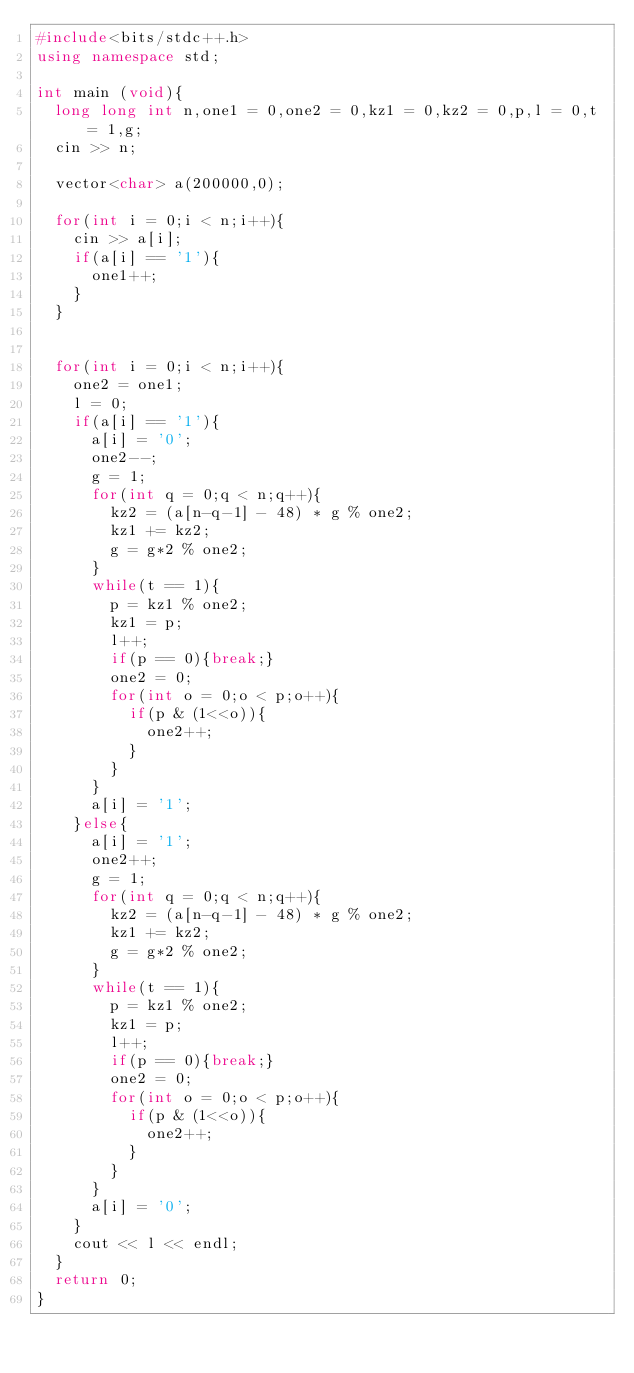<code> <loc_0><loc_0><loc_500><loc_500><_C++_>#include<bits/stdc++.h>
using namespace std;

int main (void){
  long long int n,one1 = 0,one2 = 0,kz1 = 0,kz2 = 0,p,l = 0,t = 1,g;
  cin >> n;

  vector<char> a(200000,0);

  for(int i = 0;i < n;i++){
    cin >> a[i];
    if(a[i] == '1'){
      one1++;
    }
  }


  for(int i = 0;i < n;i++){
    one2 = one1;
    l = 0;
    if(a[i] == '1'){
      a[i] = '0';
      one2--;
      g = 1;
      for(int q = 0;q < n;q++){
        kz2 = (a[n-q-1] - 48) * g % one2;
        kz1 += kz2;
        g = g*2 % one2;
      }
      while(t == 1){
        p = kz1 % one2;
        kz1 = p;
        l++;
        if(p == 0){break;}
        one2 = 0;
        for(int o = 0;o < p;o++){
          if(p & (1<<o)){
            one2++;
          }
        }
      }
      a[i] = '1';
    }else{
      a[i] = '1';
      one2++;
      g = 1;
      for(int q = 0;q < n;q++){
        kz2 = (a[n-q-1] - 48) * g % one2;
        kz1 += kz2;
        g = g*2 % one2;
      }
      while(t == 1){
        p = kz1 % one2;
        kz1 = p;
        l++;
        if(p == 0){break;}
        one2 = 0;
        for(int o = 0;o < p;o++){
          if(p & (1<<o)){
            one2++;
          }
        }
      }
      a[i] = '0';
    }
    cout << l << endl;
  }
  return 0;
}
</code> 